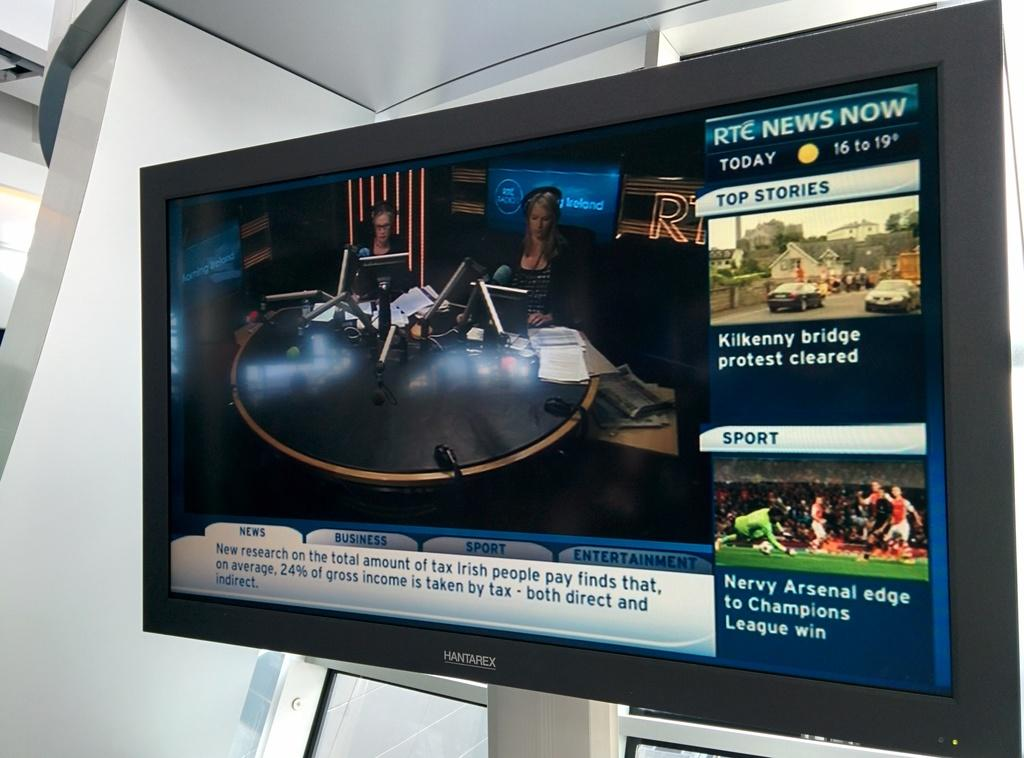<image>
Offer a succinct explanation of the picture presented. the name Arsenal is on the screen with photos above it 